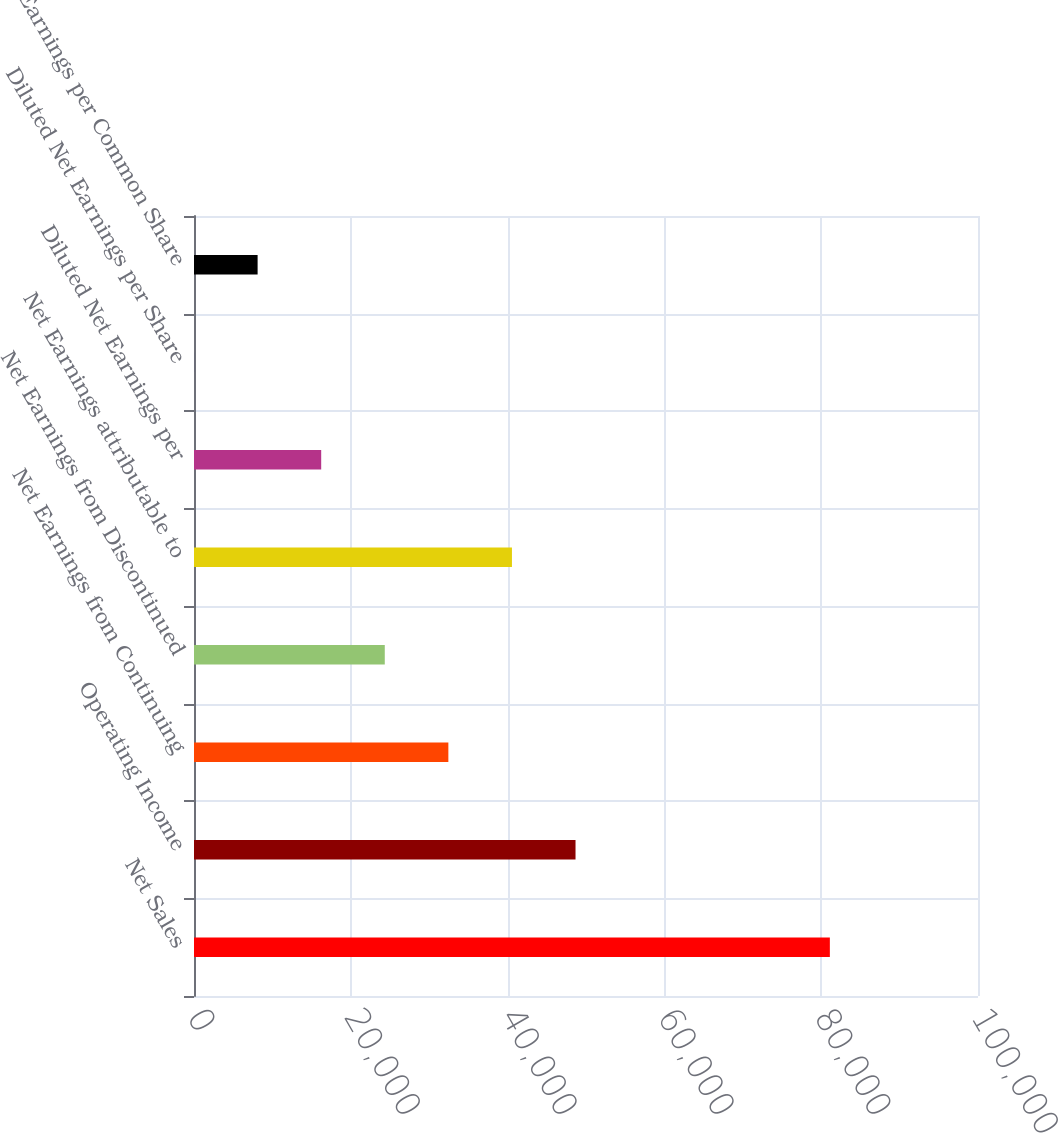Convert chart to OTSL. <chart><loc_0><loc_0><loc_500><loc_500><bar_chart><fcel>Net Sales<fcel>Operating Income<fcel>Net Earnings from Continuing<fcel>Net Earnings from Discontinued<fcel>Net Earnings attributable to<fcel>Diluted Net Earnings per<fcel>Diluted Net Earnings per Share<fcel>Core Earnings per Common Share<nl><fcel>81104<fcel>48663.9<fcel>32443.9<fcel>24333.9<fcel>40553.9<fcel>16223.9<fcel>3.85<fcel>8113.86<nl></chart> 